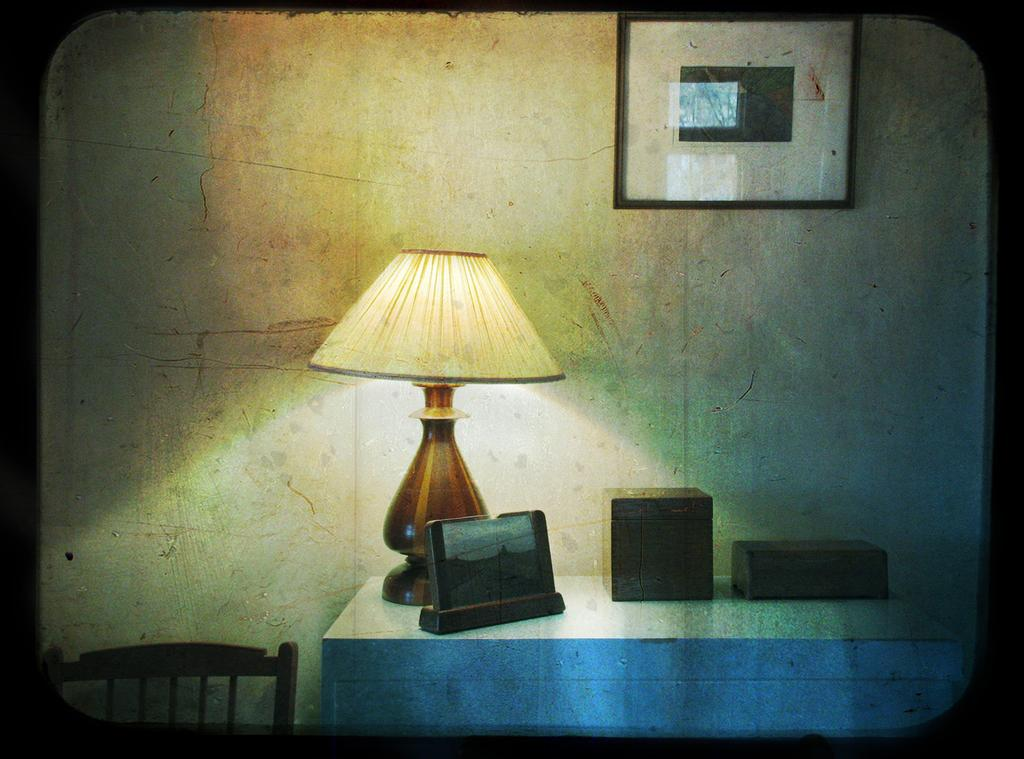What piece of furniture is present in the image? There is a table in the image. What object is placed on the table? There is a table lamp on the table. Can you describe any decorative items in the image? There is a photo frame on the wall. What type of ornament is being used in the battle depicted in the image? There is no battle or ornament present in the image. 